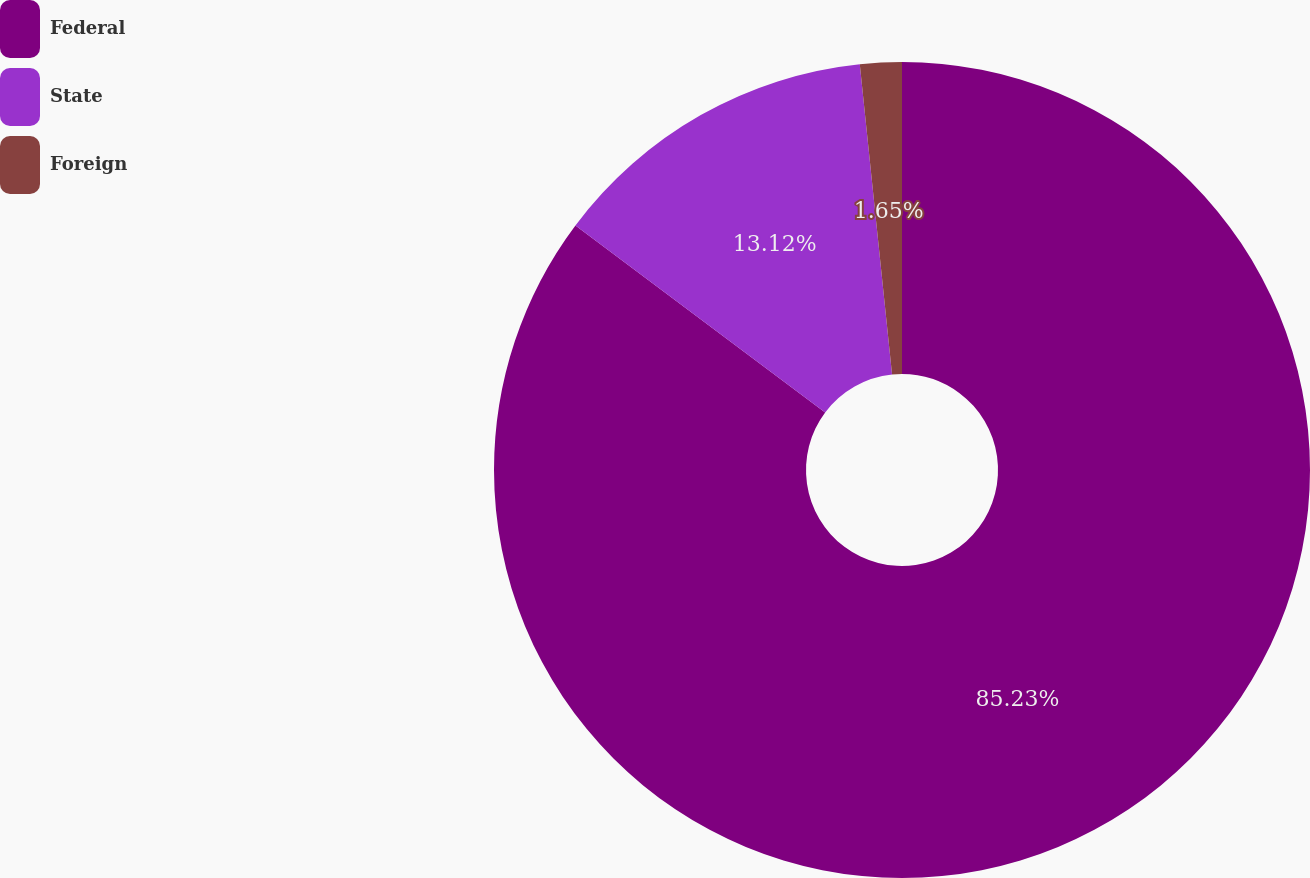<chart> <loc_0><loc_0><loc_500><loc_500><pie_chart><fcel>Federal<fcel>State<fcel>Foreign<nl><fcel>85.24%<fcel>13.12%<fcel>1.65%<nl></chart> 